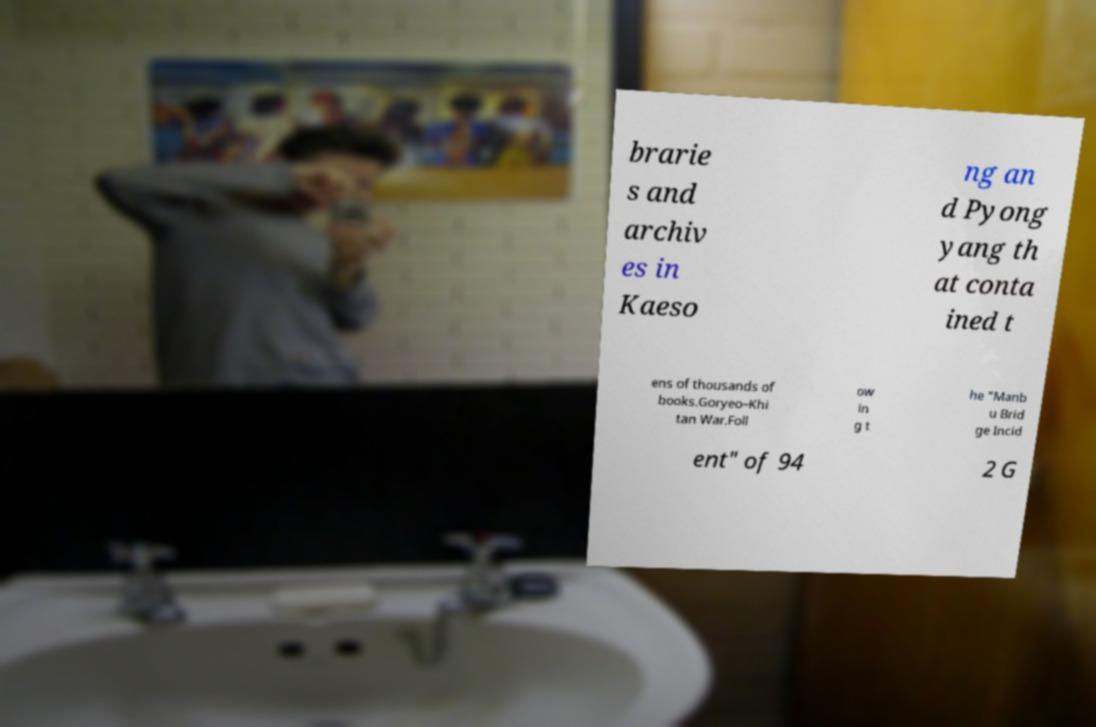Could you assist in decoding the text presented in this image and type it out clearly? brarie s and archiv es in Kaeso ng an d Pyong yang th at conta ined t ens of thousands of books.Goryeo–Khi tan War.Foll ow in g t he "Manb u Brid ge Incid ent" of 94 2 G 